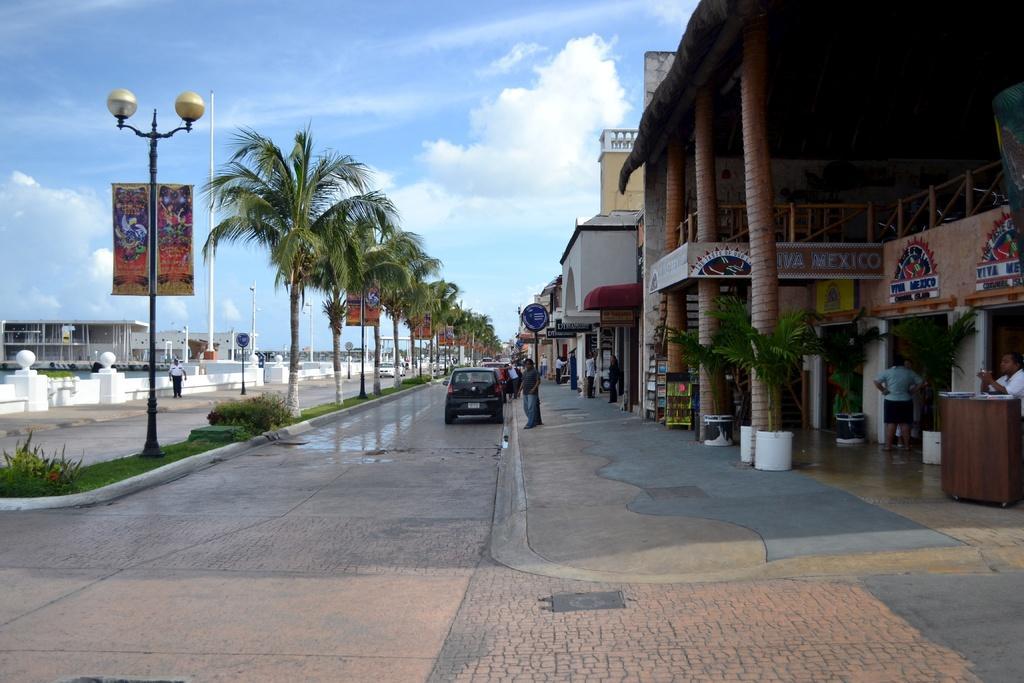How would you summarize this image in a sentence or two? This picture might be taken from outside of the city. In this image, on the right side, we can see a building, pillars, plant, flower pot. On the right side, we can see a man standing in front of the podium. On the left side, we can see some street light trees, hoardings, buildings, person. In the middle of the image, we can see group of people, cars, hoardings. On the top, we can see a sky, at the bottom there is a land. 